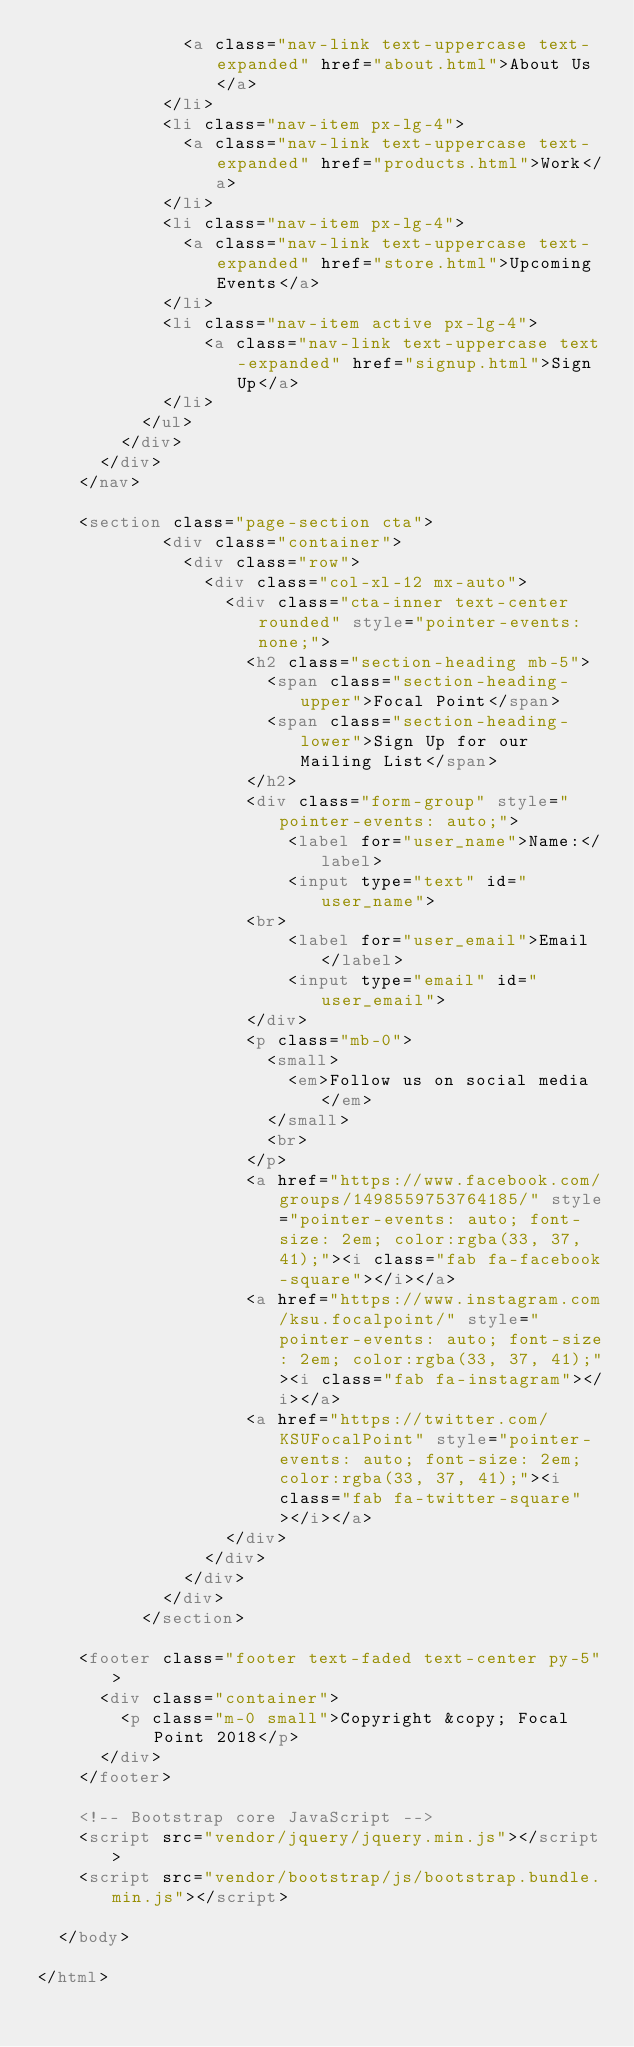Convert code to text. <code><loc_0><loc_0><loc_500><loc_500><_HTML_>              <a class="nav-link text-uppercase text-expanded" href="about.html">About Us</a>
            </li>
            <li class="nav-item px-lg-4">
              <a class="nav-link text-uppercase text-expanded" href="products.html">Work</a>
            </li>
            <li class="nav-item px-lg-4">
              <a class="nav-link text-uppercase text-expanded" href="store.html">Upcoming Events</a>
            </li>
            <li class="nav-item active px-lg-4">
                <a class="nav-link text-uppercase text-expanded" href="signup.html">Sign Up</a>
            </li>
          </ul>
        </div>
      </div>
    </nav>

    <section class="page-section cta">
            <div class="container">
              <div class="row">
                <div class="col-xl-12 mx-auto">
                  <div class="cta-inner text-center rounded" style="pointer-events:none;">
                    <h2 class="section-heading mb-5">
                      <span class="section-heading-upper">Focal Point</span>
                      <span class="section-heading-lower">Sign Up for our Mailing List</span>
                    </h2>
                    <div class="form-group" style="pointer-events: auto;">
                        <label for="user_name">Name:</label>
                        <input type="text" id="user_name">
                    <br>
                        <label for="user_email">Email</label>
                        <input type="email" id="user_email">
                    </div>
                    <p class="mb-0">
                      <small>
                        <em>Follow us on social media</em>
                      </small>
                      <br>
                    </p>
                    <a href="https://www.facebook.com/groups/1498559753764185/" style="pointer-events: auto; font-size: 2em; color:rgba(33, 37, 41);"><i class="fab fa-facebook-square"></i></a>
                    <a href="https://www.instagram.com/ksu.focalpoint/" style="pointer-events: auto; font-size: 2em; color:rgba(33, 37, 41);"><i class="fab fa-instagram"></i></a>
                    <a href="https://twitter.com/KSUFocalPoint" style="pointer-events: auto; font-size: 2em; color:rgba(33, 37, 41);"><i class="fab fa-twitter-square"></i></a>
                  </div>
                </div>
              </div>
            </div>
          </section>

    <footer class="footer text-faded text-center py-5">
      <div class="container">
        <p class="m-0 small">Copyright &copy; Focal Point 2018</p>
      </div>
    </footer>

    <!-- Bootstrap core JavaScript -->
    <script src="vendor/jquery/jquery.min.js"></script>
    <script src="vendor/bootstrap/js/bootstrap.bundle.min.js"></script>

  </body>

</html>
</code> 